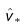<formula> <loc_0><loc_0><loc_500><loc_500>\hat { v } _ { * }</formula> 